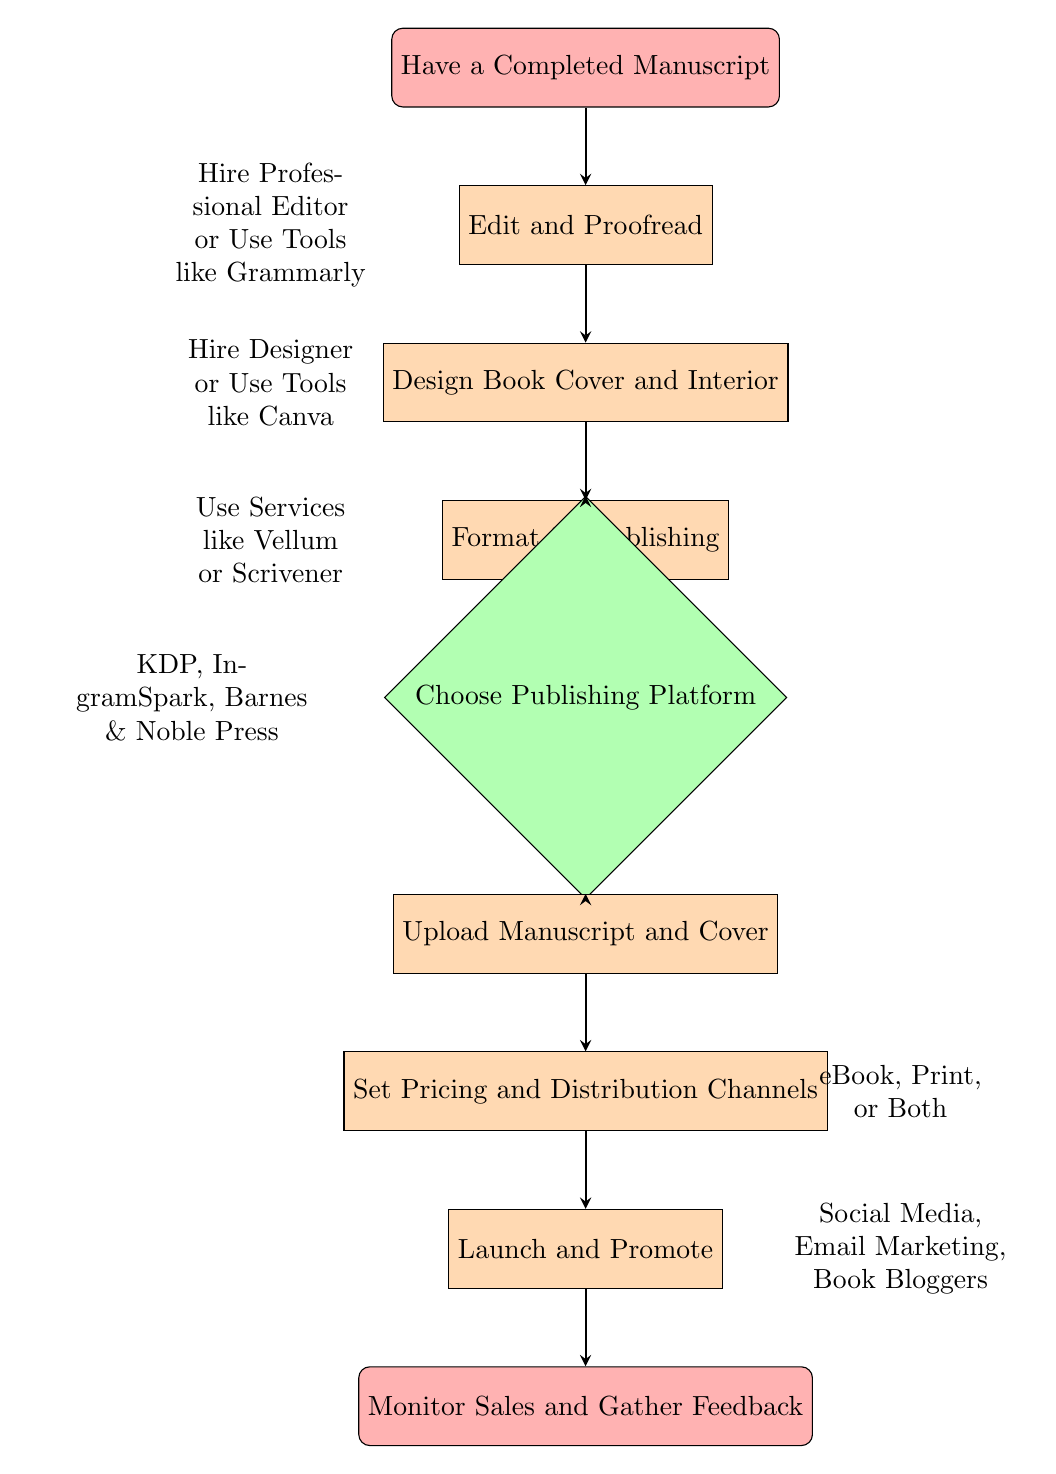What is the first step after having a completed manuscript? The first step listed in the diagram after having a completed manuscript is to edit and proofread. This can be found directly below the starting node in the flowchart.
Answer: Edit and Proofread How many main steps are there in the self-publishing process represented in the diagram? The main steps include having a completed manuscript, editing, designing the cover, formatting, choosing a platform, uploading, pricing, and launching. Counting these, there are a total of seven main steps.
Answer: Seven Which node follows the "Format for Publishing" node? The node that directly follows "Format for Publishing" is "Choose Publishing Platform". This can be tracked by moving down the flowchart from the formatting step.
Answer: Choose Publishing Platform What are the two options listed for editing and proofreading? The diagram lists two options for editing and proofreading: hiring a professional editor and using tools like Grammarly. These are indicated in the notes on the left side of the "Edit and Proofread" node.
Answer: Hire a Professional Editor or Use Tools like Grammarly What is the last step in the self-publishing process? The final step in the self-publishing process, as shown in the diagram, is to monitor sales and gather feedback. This can be confirmed by observing the last node in the chart.
Answer: Monitor Sales and Gather Feedback What is one of the services that can be used for formatting? According to the diagram, one of the services that can be used for formatting is Vellum. This is confirmed by the text that is positioned left of the "Format for Publishing" node.
Answer: Vellum Which publishing platform option is mentioned first? The first option mentioned for choosing a publishing platform in the diagram is Amazon Kindle Direct Publishing (KDP). This can be identified by looking directly below the "Choose Publishing Platform" decision node.
Answer: Amazon Kindle Direct Publishing (KDP) What promotional method involves engaging with readers directly? According to the diagram, engaging in email marketing is a promotional method that involves direct interaction with readers. This is indicated in the notes next to the "Launch and Promote" node.
Answer: Engage in Email Marketing 